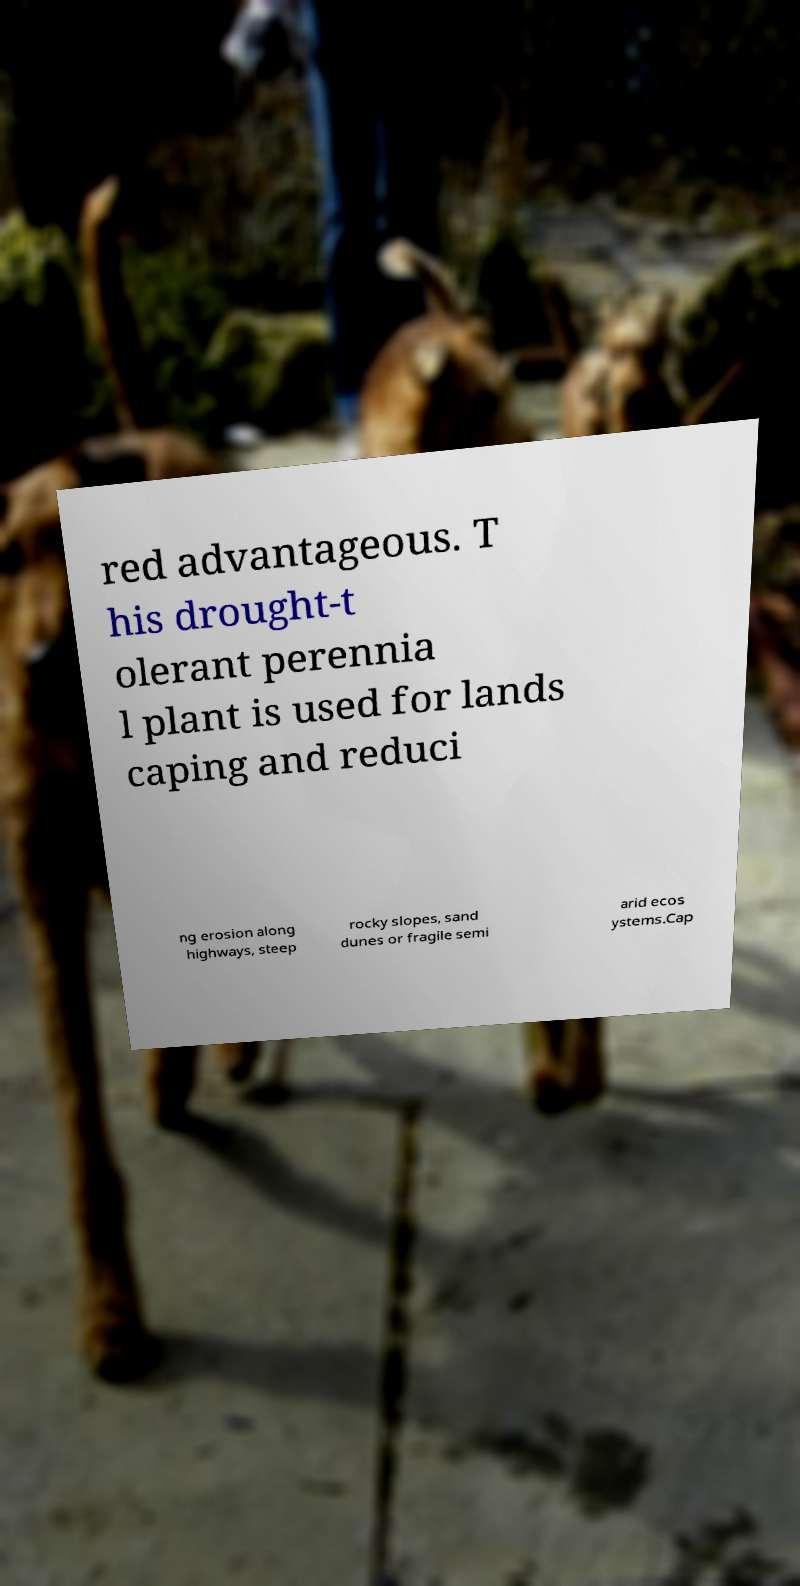What messages or text are displayed in this image? I need them in a readable, typed format. red advantageous. T his drought-t olerant perennia l plant is used for lands caping and reduci ng erosion along highways, steep rocky slopes, sand dunes or fragile semi arid ecos ystems.Cap 